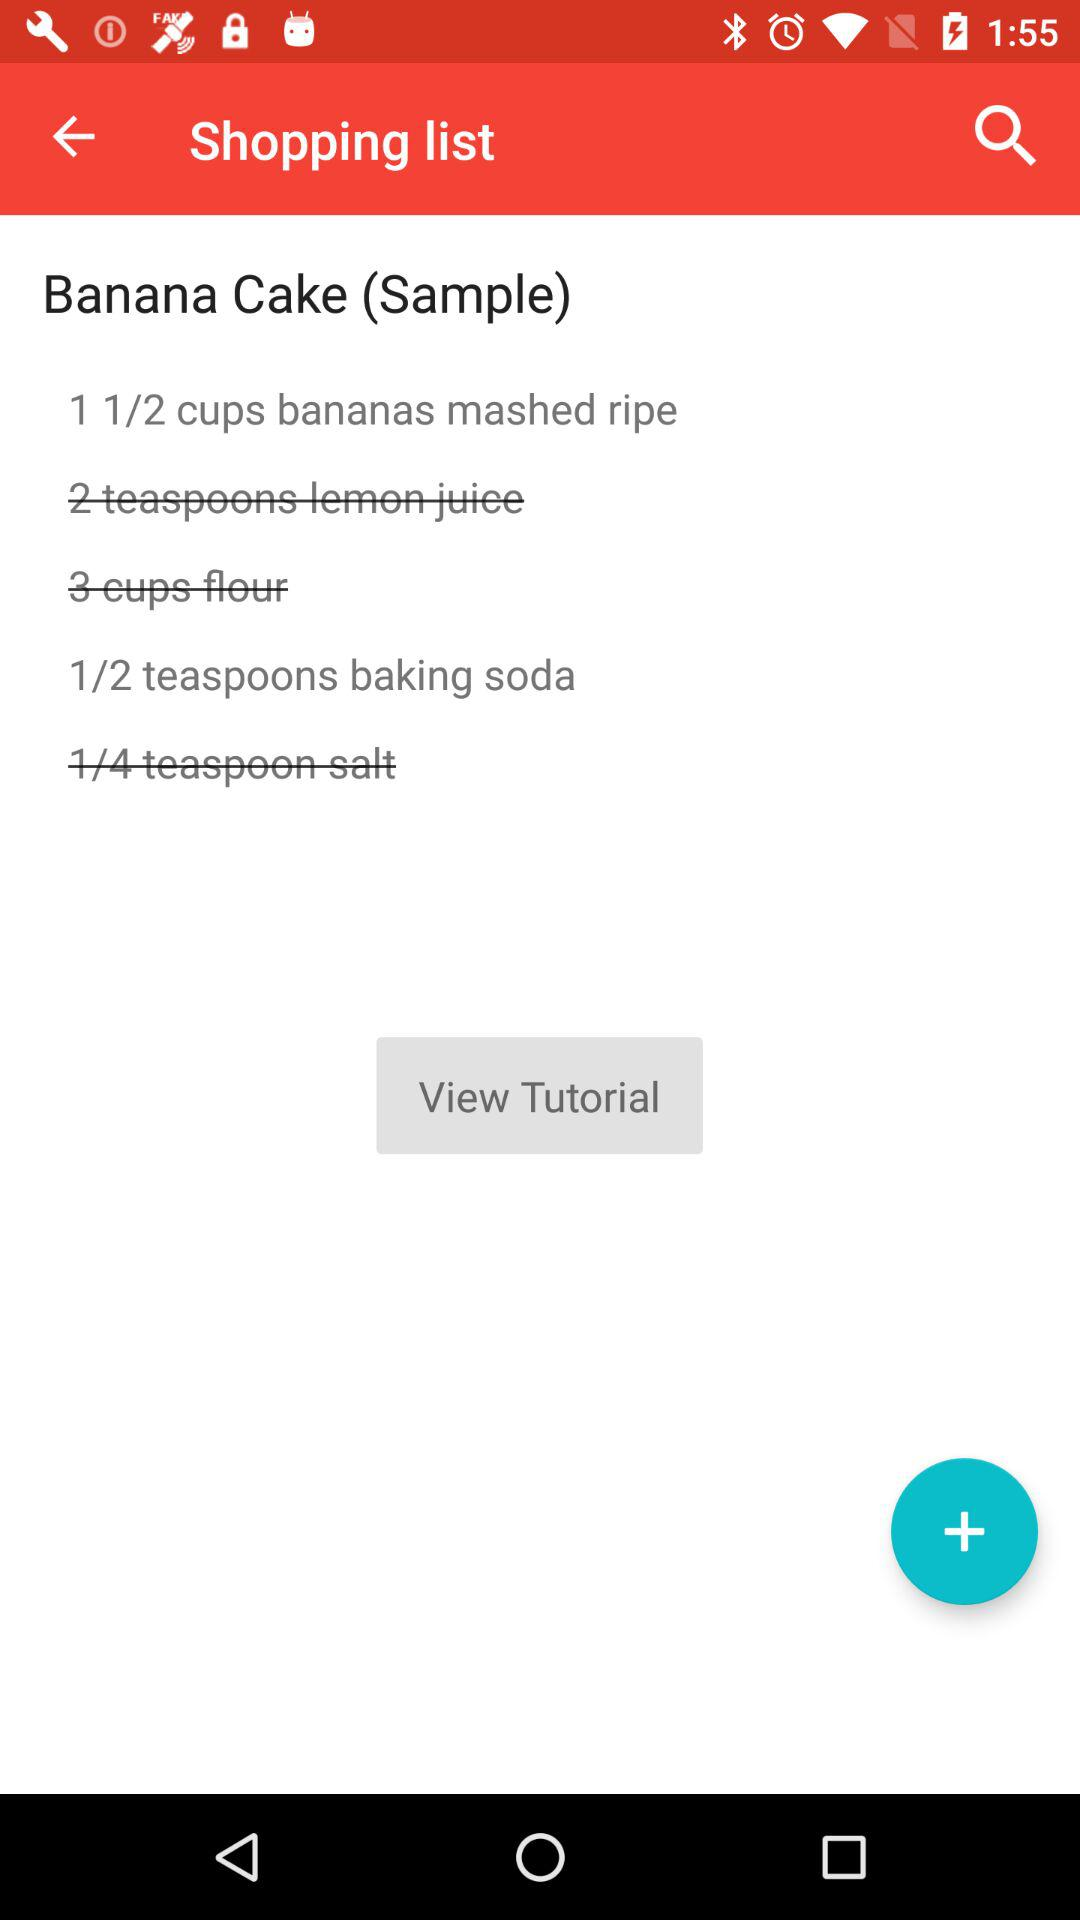How many calories are in "Banana Cake"?
When the provided information is insufficient, respond with <no answer>. <no answer> 